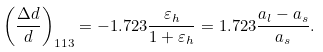<formula> <loc_0><loc_0><loc_500><loc_500>\left ( \frac { \Delta d } { d } \right ) _ { 1 1 3 } = - 1 . 7 2 3 \frac { \varepsilon _ { h } } { 1 + \varepsilon _ { h } } = 1 . 7 2 3 \frac { a _ { l } - a _ { s } } { a _ { s } } .</formula> 